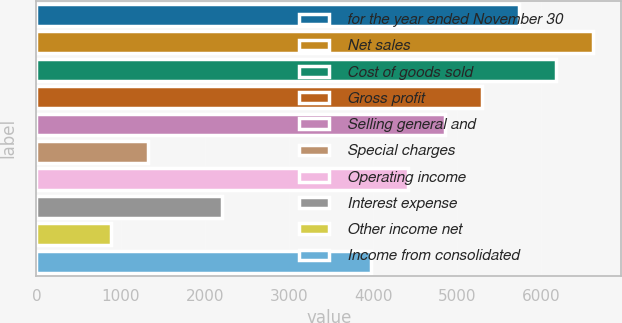Convert chart. <chart><loc_0><loc_0><loc_500><loc_500><bar_chart><fcel>for the year ended November 30<fcel>Net sales<fcel>Cost of goods sold<fcel>Gross profit<fcel>Selling general and<fcel>Special charges<fcel>Operating income<fcel>Interest expense<fcel>Other income net<fcel>Income from consolidated<nl><fcel>5733.83<fcel>6615.39<fcel>6174.61<fcel>5293.05<fcel>4852.27<fcel>1326.03<fcel>4411.49<fcel>2207.59<fcel>885.25<fcel>3970.71<nl></chart> 